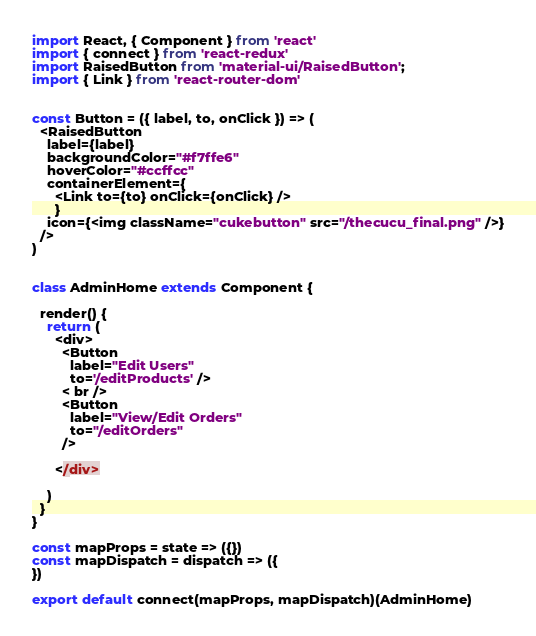<code> <loc_0><loc_0><loc_500><loc_500><_JavaScript_>import React, { Component } from 'react'
import { connect } from 'react-redux'
import RaisedButton from 'material-ui/RaisedButton';
import { Link } from 'react-router-dom'


const Button = ({ label, to, onClick }) => (
  <RaisedButton
    label={label}
    backgroundColor="#f7ffe6"
    hoverColor="#ccffcc"
    containerElement={
      <Link to={to} onClick={onClick} />
      }
    icon={<img className="cukebutton" src="/thecucu_final.png" />}
  />
)


class AdminHome extends Component {

  render() {
    return (
      <div>
        <Button
          label="Edit Users"
          to='/editProducts' />
        < br />
        <Button
          label="View/Edit Orders"
          to="/editOrders"
        />

      </div>

    )
  }
}

const mapProps = state => ({})
const mapDispatch = dispatch => ({
})

export default connect(mapProps, mapDispatch)(AdminHome)
</code> 